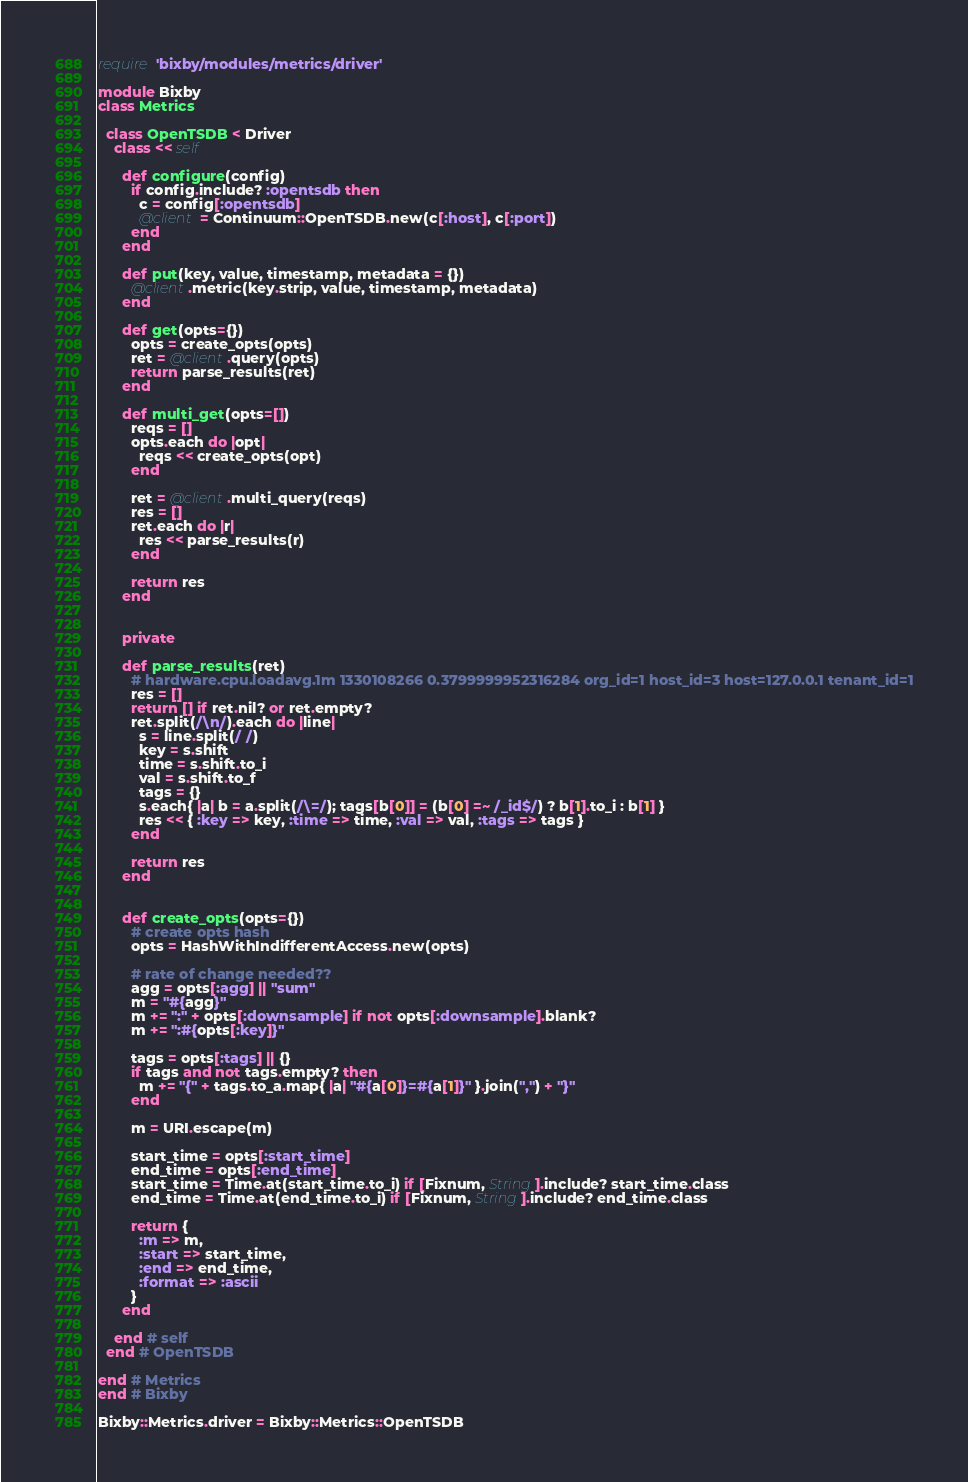Convert code to text. <code><loc_0><loc_0><loc_500><loc_500><_Ruby_>
require 'bixby/modules/metrics/driver'

module Bixby
class Metrics

  class OpenTSDB < Driver
    class << self

      def configure(config)
        if config.include? :opentsdb then
          c = config[:opentsdb]
          @client = Continuum::OpenTSDB.new(c[:host], c[:port])
        end
      end

      def put(key, value, timestamp, metadata = {})
        @client.metric(key.strip, value, timestamp, metadata)
      end

      def get(opts={})
        opts = create_opts(opts)
        ret = @client.query(opts)
        return parse_results(ret)
      end

      def multi_get(opts=[])
        reqs = []
        opts.each do |opt|
          reqs << create_opts(opt)
        end

        ret = @client.multi_query(reqs)
        res = []
        ret.each do |r|
          res << parse_results(r)
        end

        return res
      end


      private

      def parse_results(ret)
        # hardware.cpu.loadavg.1m 1330108266 0.3799999952316284 org_id=1 host_id=3 host=127.0.0.1 tenant_id=1
        res = []
        return [] if ret.nil? or ret.empty?
        ret.split(/\n/).each do |line|
          s = line.split(/ /)
          key = s.shift
          time = s.shift.to_i
          val = s.shift.to_f
          tags = {}
          s.each{ |a| b = a.split(/\=/); tags[b[0]] = (b[0] =~ /_id$/) ? b[1].to_i : b[1] }
          res << { :key => key, :time => time, :val => val, :tags => tags }
        end

        return res
      end


      def create_opts(opts={})
        # create opts hash
        opts = HashWithIndifferentAccess.new(opts)

        # rate of change needed??
        agg = opts[:agg] || "sum"
        m = "#{agg}"
        m += ":" + opts[:downsample] if not opts[:downsample].blank?
        m += ":#{opts[:key]}"

        tags = opts[:tags] || {}
        if tags and not tags.empty? then
          m += "{" + tags.to_a.map{ |a| "#{a[0]}=#{a[1]}" }.join(",") + "}"
        end

        m = URI.escape(m)

        start_time = opts[:start_time]
        end_time = opts[:end_time]
        start_time = Time.at(start_time.to_i) if [Fixnum, String].include? start_time.class
        end_time = Time.at(end_time.to_i) if [Fixnum, String].include? end_time.class

        return {
          :m => m,
          :start => start_time,
          :end => end_time,
          :format => :ascii
        }
      end

    end # self
  end # OpenTSDB

end # Metrics
end # Bixby

Bixby::Metrics.driver = Bixby::Metrics::OpenTSDB
</code> 